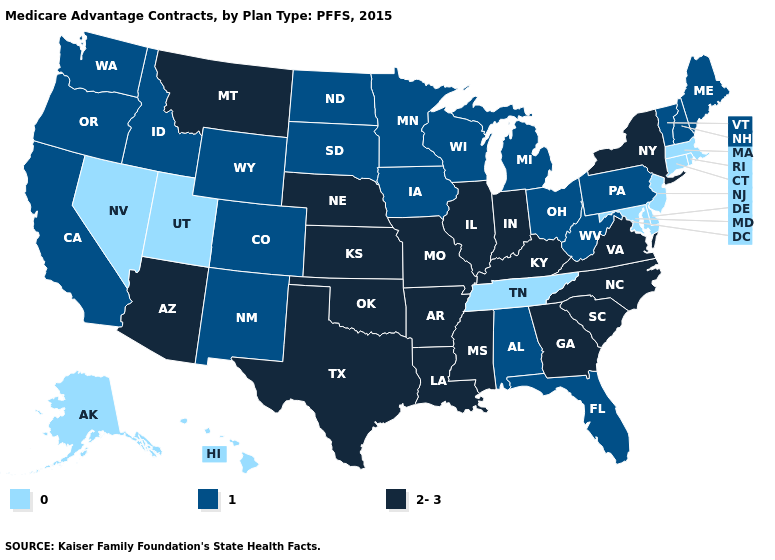Name the states that have a value in the range 2-3?
Write a very short answer. Arkansas, Arizona, Georgia, Illinois, Indiana, Kansas, Kentucky, Louisiana, Missouri, Mississippi, Montana, North Carolina, Nebraska, New York, Oklahoma, South Carolina, Texas, Virginia. Which states have the lowest value in the USA?
Keep it brief. Alaska, Connecticut, Delaware, Hawaii, Massachusetts, Maryland, New Jersey, Nevada, Rhode Island, Tennessee, Utah. What is the value of Alaska?
Be succinct. 0. Name the states that have a value in the range 1?
Keep it brief. Alabama, California, Colorado, Florida, Iowa, Idaho, Maine, Michigan, Minnesota, North Dakota, New Hampshire, New Mexico, Ohio, Oregon, Pennsylvania, South Dakota, Vermont, Washington, Wisconsin, West Virginia, Wyoming. What is the value of Massachusetts?
Give a very brief answer. 0. Name the states that have a value in the range 1?
Write a very short answer. Alabama, California, Colorado, Florida, Iowa, Idaho, Maine, Michigan, Minnesota, North Dakota, New Hampshire, New Mexico, Ohio, Oregon, Pennsylvania, South Dakota, Vermont, Washington, Wisconsin, West Virginia, Wyoming. How many symbols are there in the legend?
Be succinct. 3. Does the first symbol in the legend represent the smallest category?
Keep it brief. Yes. How many symbols are there in the legend?
Keep it brief. 3. What is the value of Washington?
Write a very short answer. 1. Among the states that border Florida , which have the highest value?
Give a very brief answer. Georgia. Name the states that have a value in the range 0?
Give a very brief answer. Alaska, Connecticut, Delaware, Hawaii, Massachusetts, Maryland, New Jersey, Nevada, Rhode Island, Tennessee, Utah. Does Louisiana have the highest value in the USA?
Short answer required. Yes. What is the highest value in the Northeast ?
Keep it brief. 2-3. 